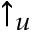Convert formula to latex. <formula><loc_0><loc_0><loc_500><loc_500>\uparrow _ { u }</formula> 